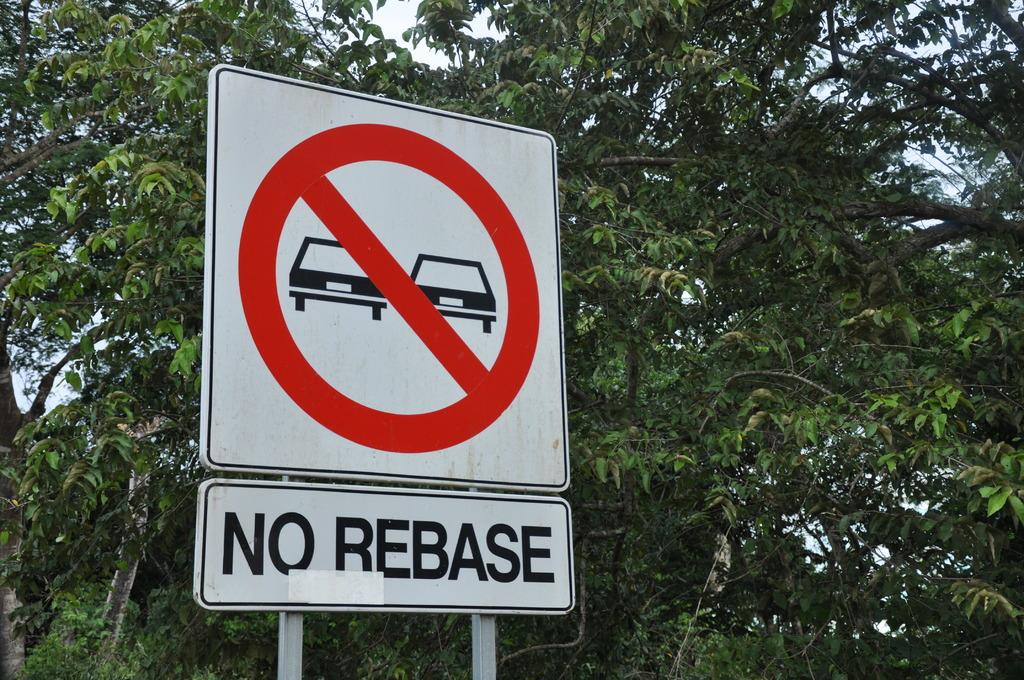What is on the sign board in the image? There is a sign board with text in the image. What type of natural elements can be seen in the image? There are trees visible in the image. What part of the natural environment is visible in the image? The sky is visible in the image. Can you tell me what the queen is doing in the image? There is no queen present in the image. What type of rifle can be seen in the image? There is no rifle present in the image. 